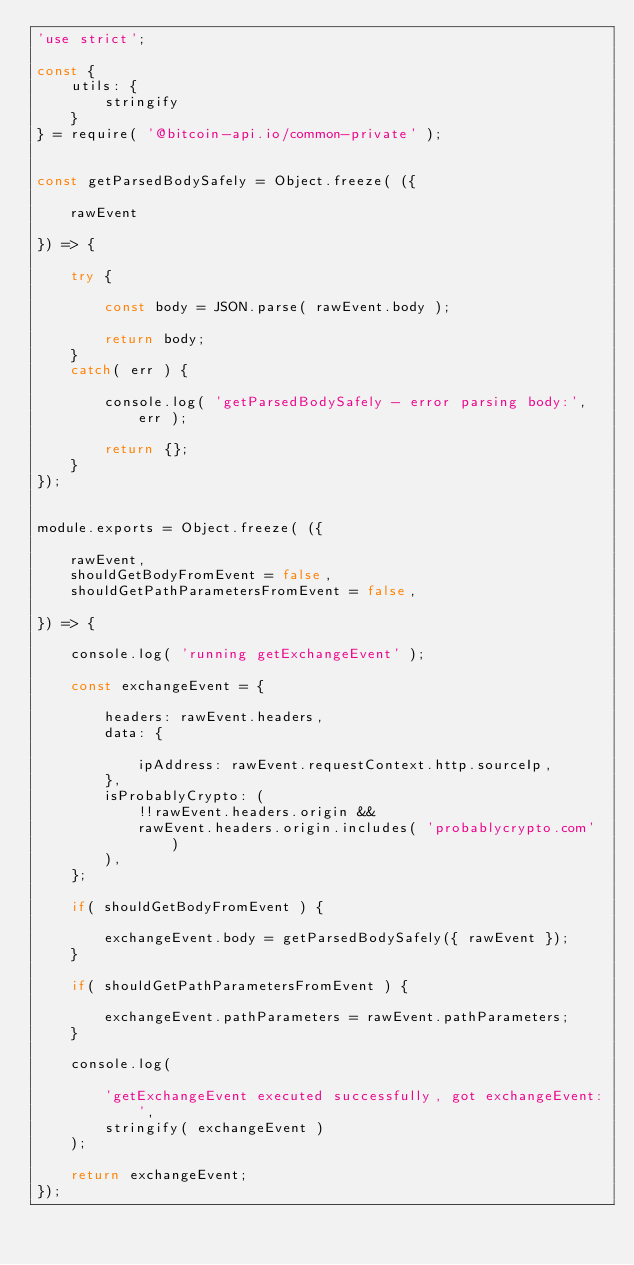<code> <loc_0><loc_0><loc_500><loc_500><_JavaScript_>'use strict';

const {
    utils: {
        stringify
    }
} = require( '@bitcoin-api.io/common-private' );


const getParsedBodySafely = Object.freeze( ({

    rawEvent

}) => {

    try {
        
        const body = JSON.parse( rawEvent.body );

        return body;
    }
    catch( err ) {
        
        console.log( 'getParsedBodySafely - error parsing body:', err );

        return {};
    }
});


module.exports = Object.freeze( ({
    
    rawEvent,
    shouldGetBodyFromEvent = false,
    shouldGetPathParametersFromEvent = false,

}) => {
    
    console.log( 'running getExchangeEvent' );

    const exchangeEvent = {

        headers: rawEvent.headers,
        data: {

            ipAddress: rawEvent.requestContext.http.sourceIp,
        },
        isProbablyCrypto: (
            !!rawEvent.headers.origin &&
            rawEvent.headers.origin.includes( 'probablycrypto.com' )
        ),
    };

    if( shouldGetBodyFromEvent ) {

        exchangeEvent.body = getParsedBodySafely({ rawEvent });
    }

    if( shouldGetPathParametersFromEvent ) {

        exchangeEvent.pathParameters = rawEvent.pathParameters;
    }

    console.log(
        
        'getExchangeEvent executed successfully, got exchangeEvent:',
        stringify( exchangeEvent )
    );

    return exchangeEvent;
});
</code> 